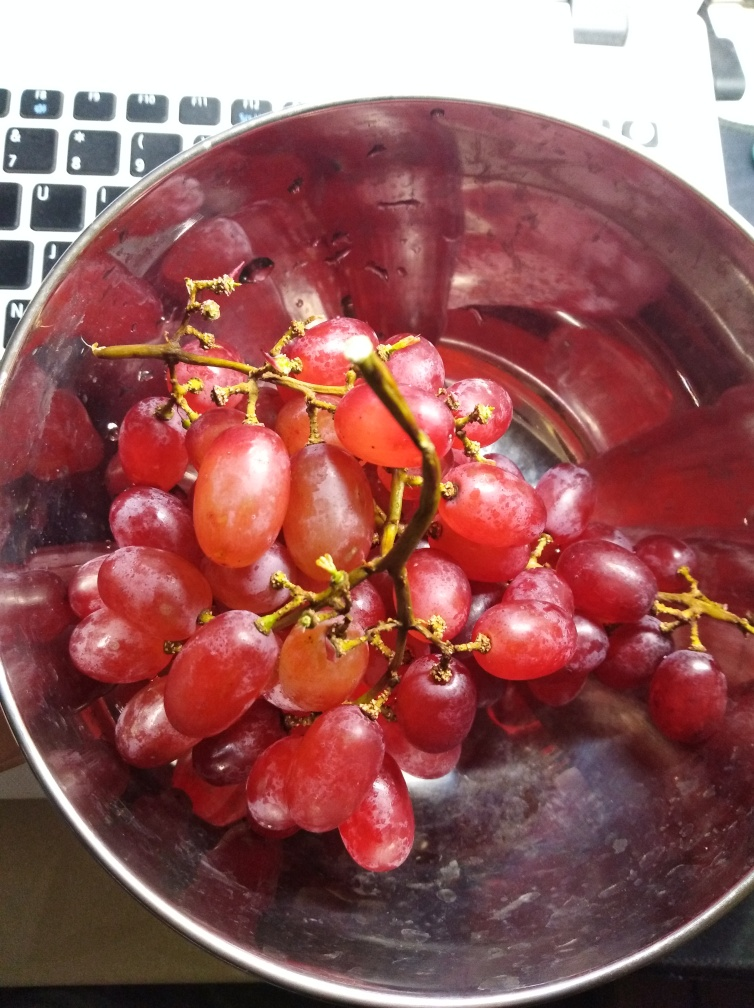Could you provide a brief description of the setting in which these grapes are placed? Certainly! The grapes are situated in a reflective metal bowl, which appears to be stainless steel due to its silvery tone and polished surface that mirrors the surrounding environment. The contrast between the natural, organic form of the grapes and the industrial, smooth surface of the bowl creates a visually appealing composition. Additionally, the grapes are positioned next to what seems to be a keyboard, suggesting the setting may be an office or home workspace where someone might enjoy a healthy snack while working. 